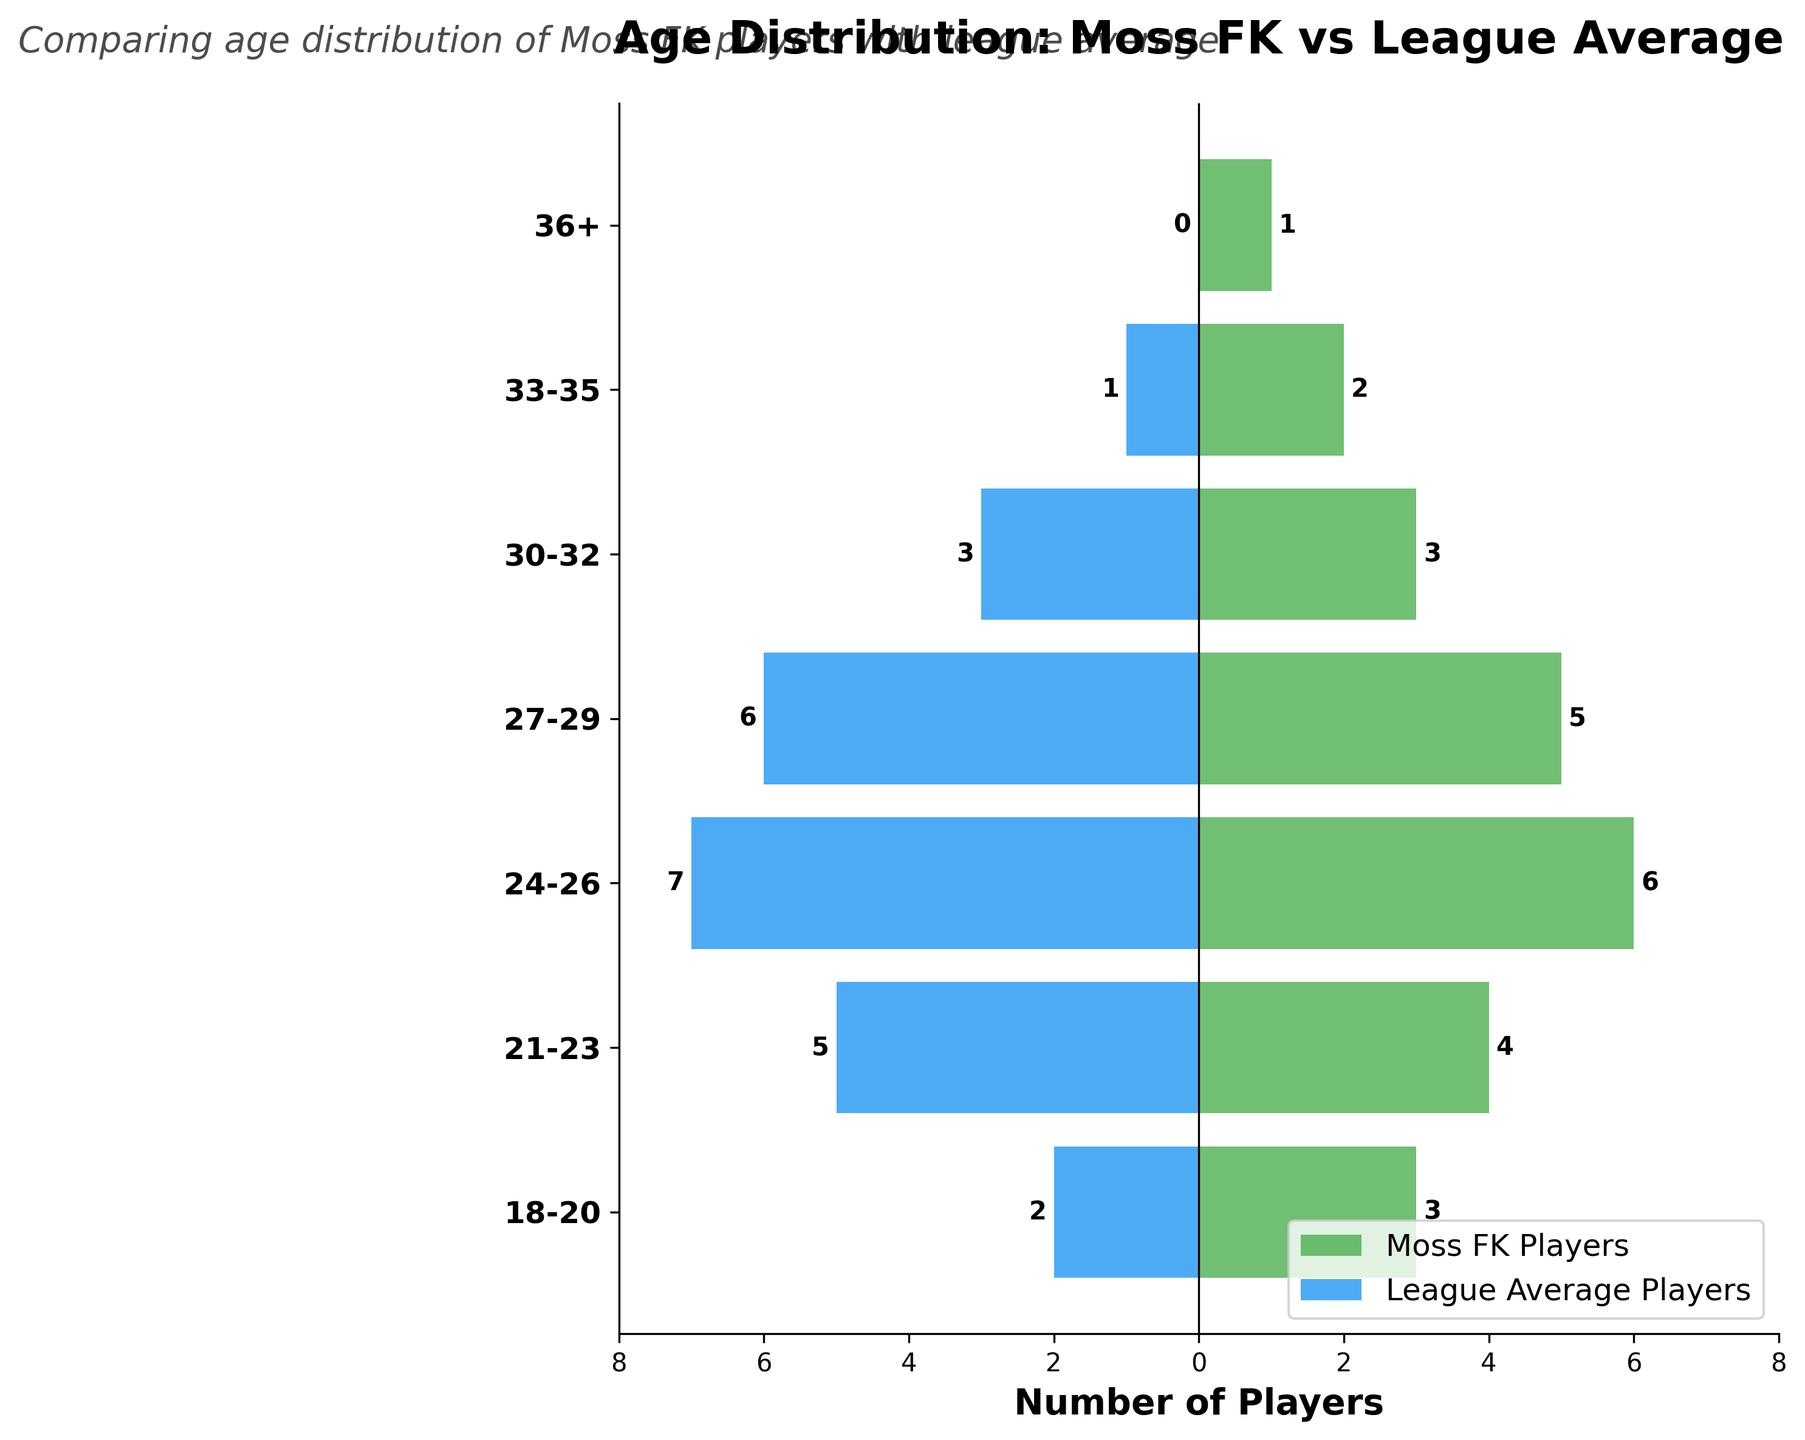What is the title of the figure? The title is usually located at the top of the figure. In this case, the title is "Age Distribution: Moss FK vs League Average".
Answer: Age Distribution: Moss FK vs League Average How many players aged 18-20 are there in Moss FK? Look at the bar corresponding to the 18-20 age group in the axis labeled 'Moss FK Players'. Count the number of players indicated by the bar.
Answer: 3 Which age group has more players in Moss FK compared to the league average? Compare the bars for Moss FK and the league average for each age group. Find the age group where the Moss FK bar is longer than the league average bar.
Answer: 33-35 and 36+ How many players aged 27-29 are there in the league average? Look at the bar corresponding to the 27-29 age group in the axis labeled 'League Average Players'. Count the number of players indicated by the bar and take the absolute value since the bars for the league average are negative.
Answer: 6 Which age group has the highest number of players in Moss FK? Identify the bar with the greatest positive length on the 'Moss FK Players' side. The highest bar corresponds to the most populous age group.
Answer: 24-26 What's the difference in the number of players aged 21-23 between Moss FK and the league average? Find the number of players in the 21-23 age group for both Moss FK and the league average. Subtract the league average from the Moss FK number.
Answer: -1 What is the combined total number of players aged 33-35 and 36+ in Moss FK? Add the number of players in the age groups 33-35 and 36+ for Moss FK.
Answer: 3 How many age groups have a higher number of Moss FK players than the league average? Compare the bars for each age group. Count the number of age groups where the Moss FK bar is longer than the league average bar.
Answer: 3 Which age group has the fewest players for Moss FK? Identify the bar with the smallest positive length on the 'Moss FK Players' side.
Answer: 36+ Does the league average have any players in the 36+ age group? Check the bar corresponding to the 36+ age group in the axis labeled 'League Average Players'. If the bar length is zero, then the league average has no players in this age group.
Answer: No 